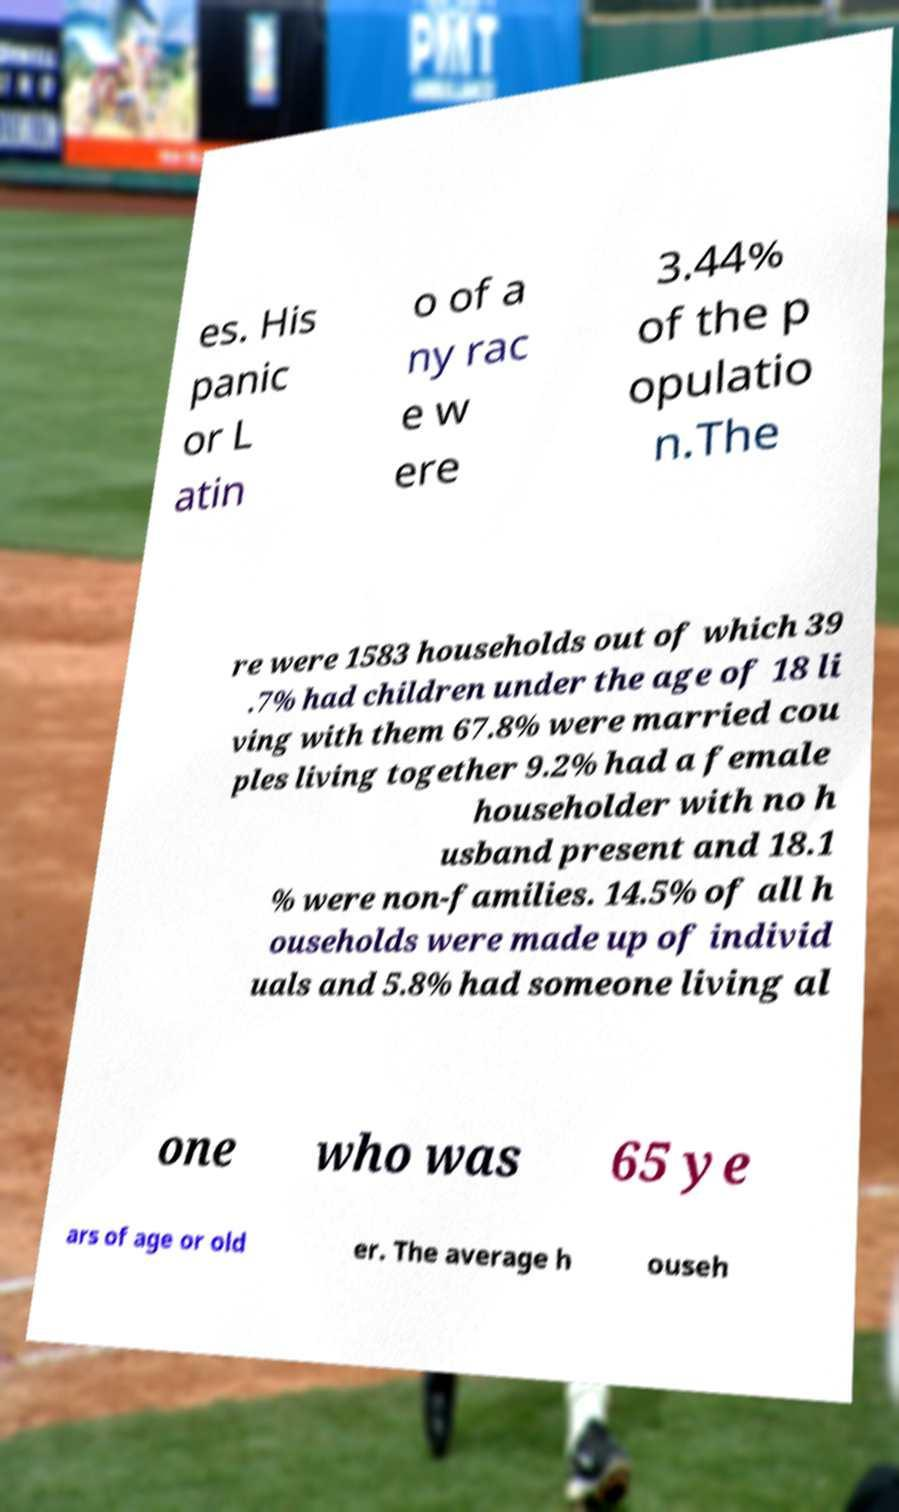Please identify and transcribe the text found in this image. es. His panic or L atin o of a ny rac e w ere 3.44% of the p opulatio n.The re were 1583 households out of which 39 .7% had children under the age of 18 li ving with them 67.8% were married cou ples living together 9.2% had a female householder with no h usband present and 18.1 % were non-families. 14.5% of all h ouseholds were made up of individ uals and 5.8% had someone living al one who was 65 ye ars of age or old er. The average h ouseh 